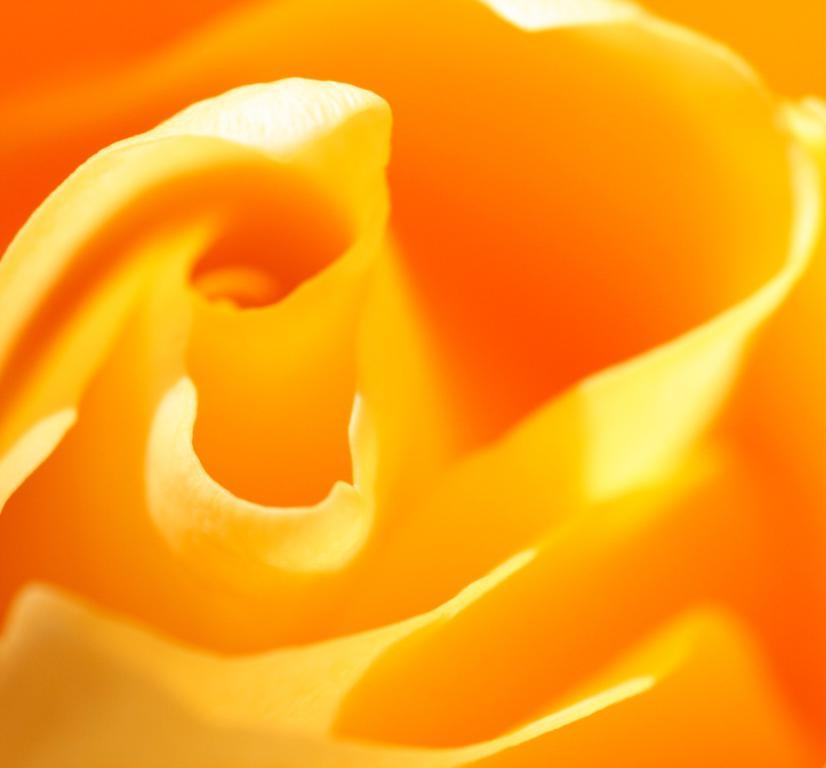What type of flower is present in the image? There is a yellow color flower in the image. What type of yam is being used to create the flower design in the image? There is no yam or design present in the image; it features a yellow color flower. 